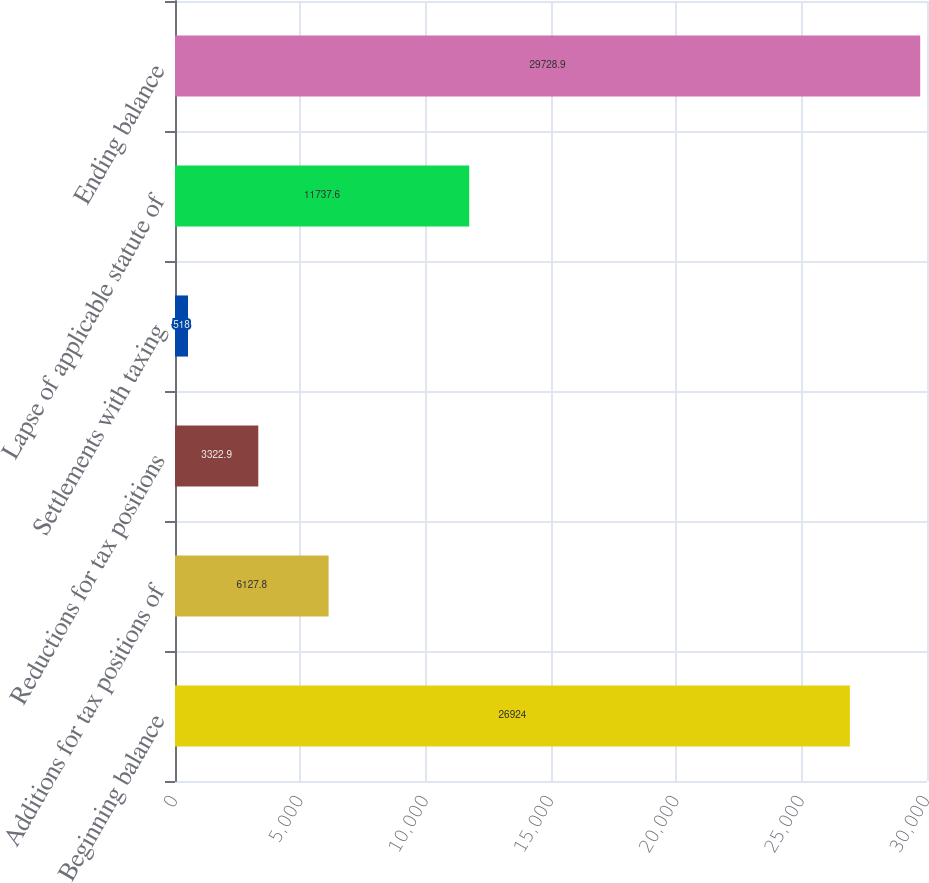Convert chart. <chart><loc_0><loc_0><loc_500><loc_500><bar_chart><fcel>Beginning balance<fcel>Additions for tax positions of<fcel>Reductions for tax positions<fcel>Settlements with taxing<fcel>Lapse of applicable statute of<fcel>Ending balance<nl><fcel>26924<fcel>6127.8<fcel>3322.9<fcel>518<fcel>11737.6<fcel>29728.9<nl></chart> 